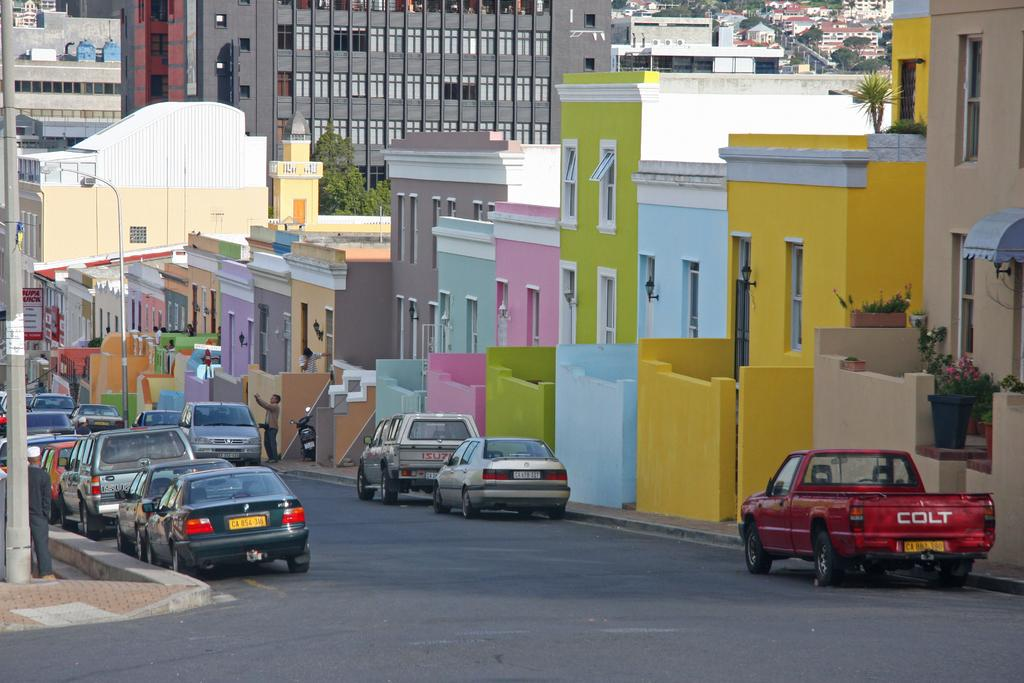<image>
Describe the image concisely. One of the cars parked on this street is a Colt pickup truck. 